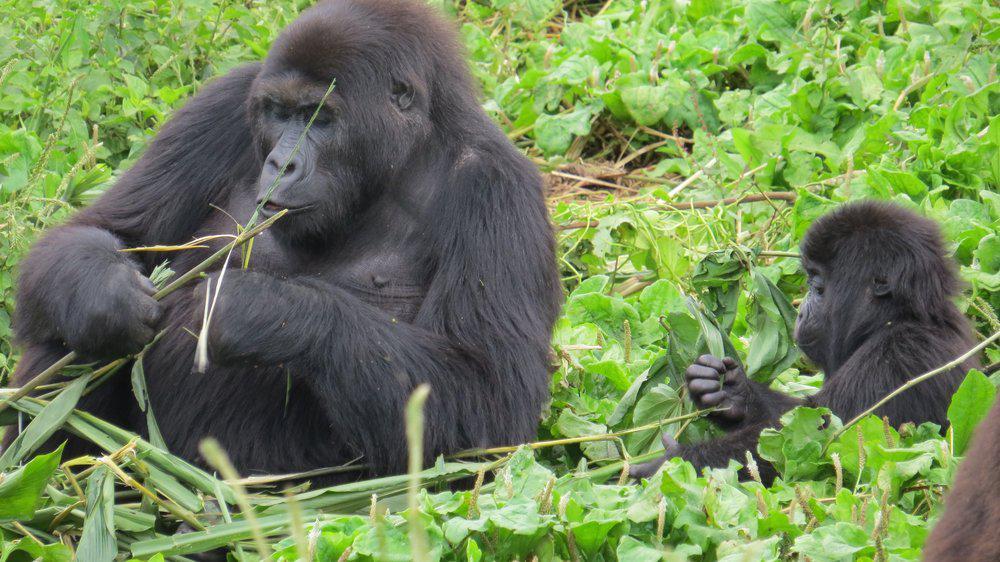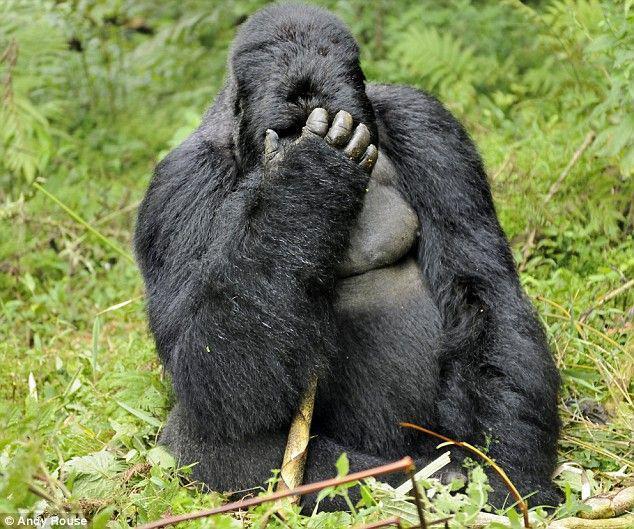The first image is the image on the left, the second image is the image on the right. Evaluate the accuracy of this statement regarding the images: "A gorilla is eating a plant in one of the images.". Is it true? Answer yes or no. Yes. The first image is the image on the left, the second image is the image on the right. Analyze the images presented: Is the assertion "In at least one image, a large gorilla has its elbow bent and its hand raised towards its face." valid? Answer yes or no. Yes. 